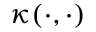Convert formula to latex. <formula><loc_0><loc_0><loc_500><loc_500>\kappa ( \cdot , \cdot )</formula> 